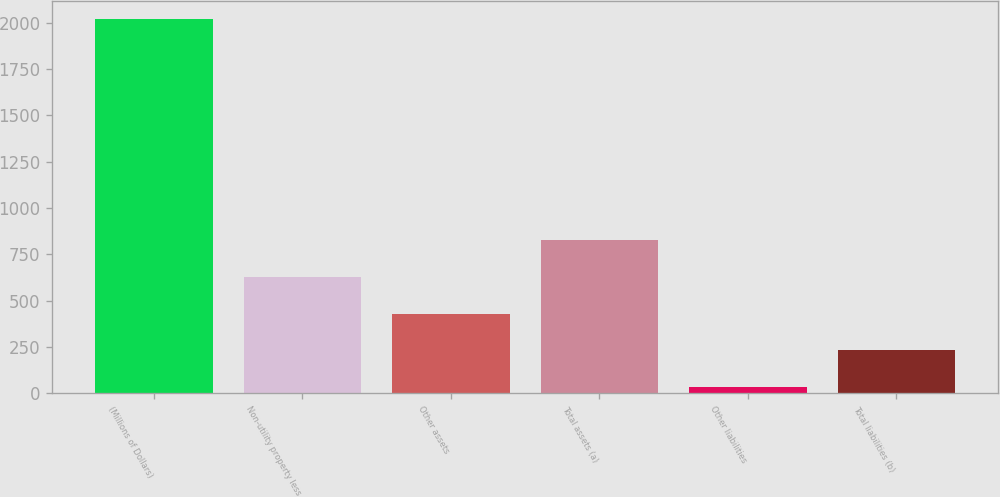Convert chart to OTSL. <chart><loc_0><loc_0><loc_500><loc_500><bar_chart><fcel>(Millions of Dollars)<fcel>Non-utility property less<fcel>Other assets<fcel>Total assets (a)<fcel>Other liabilities<fcel>Total liabilities (b)<nl><fcel>2018<fcel>628.5<fcel>430<fcel>827<fcel>33<fcel>231.5<nl></chart> 